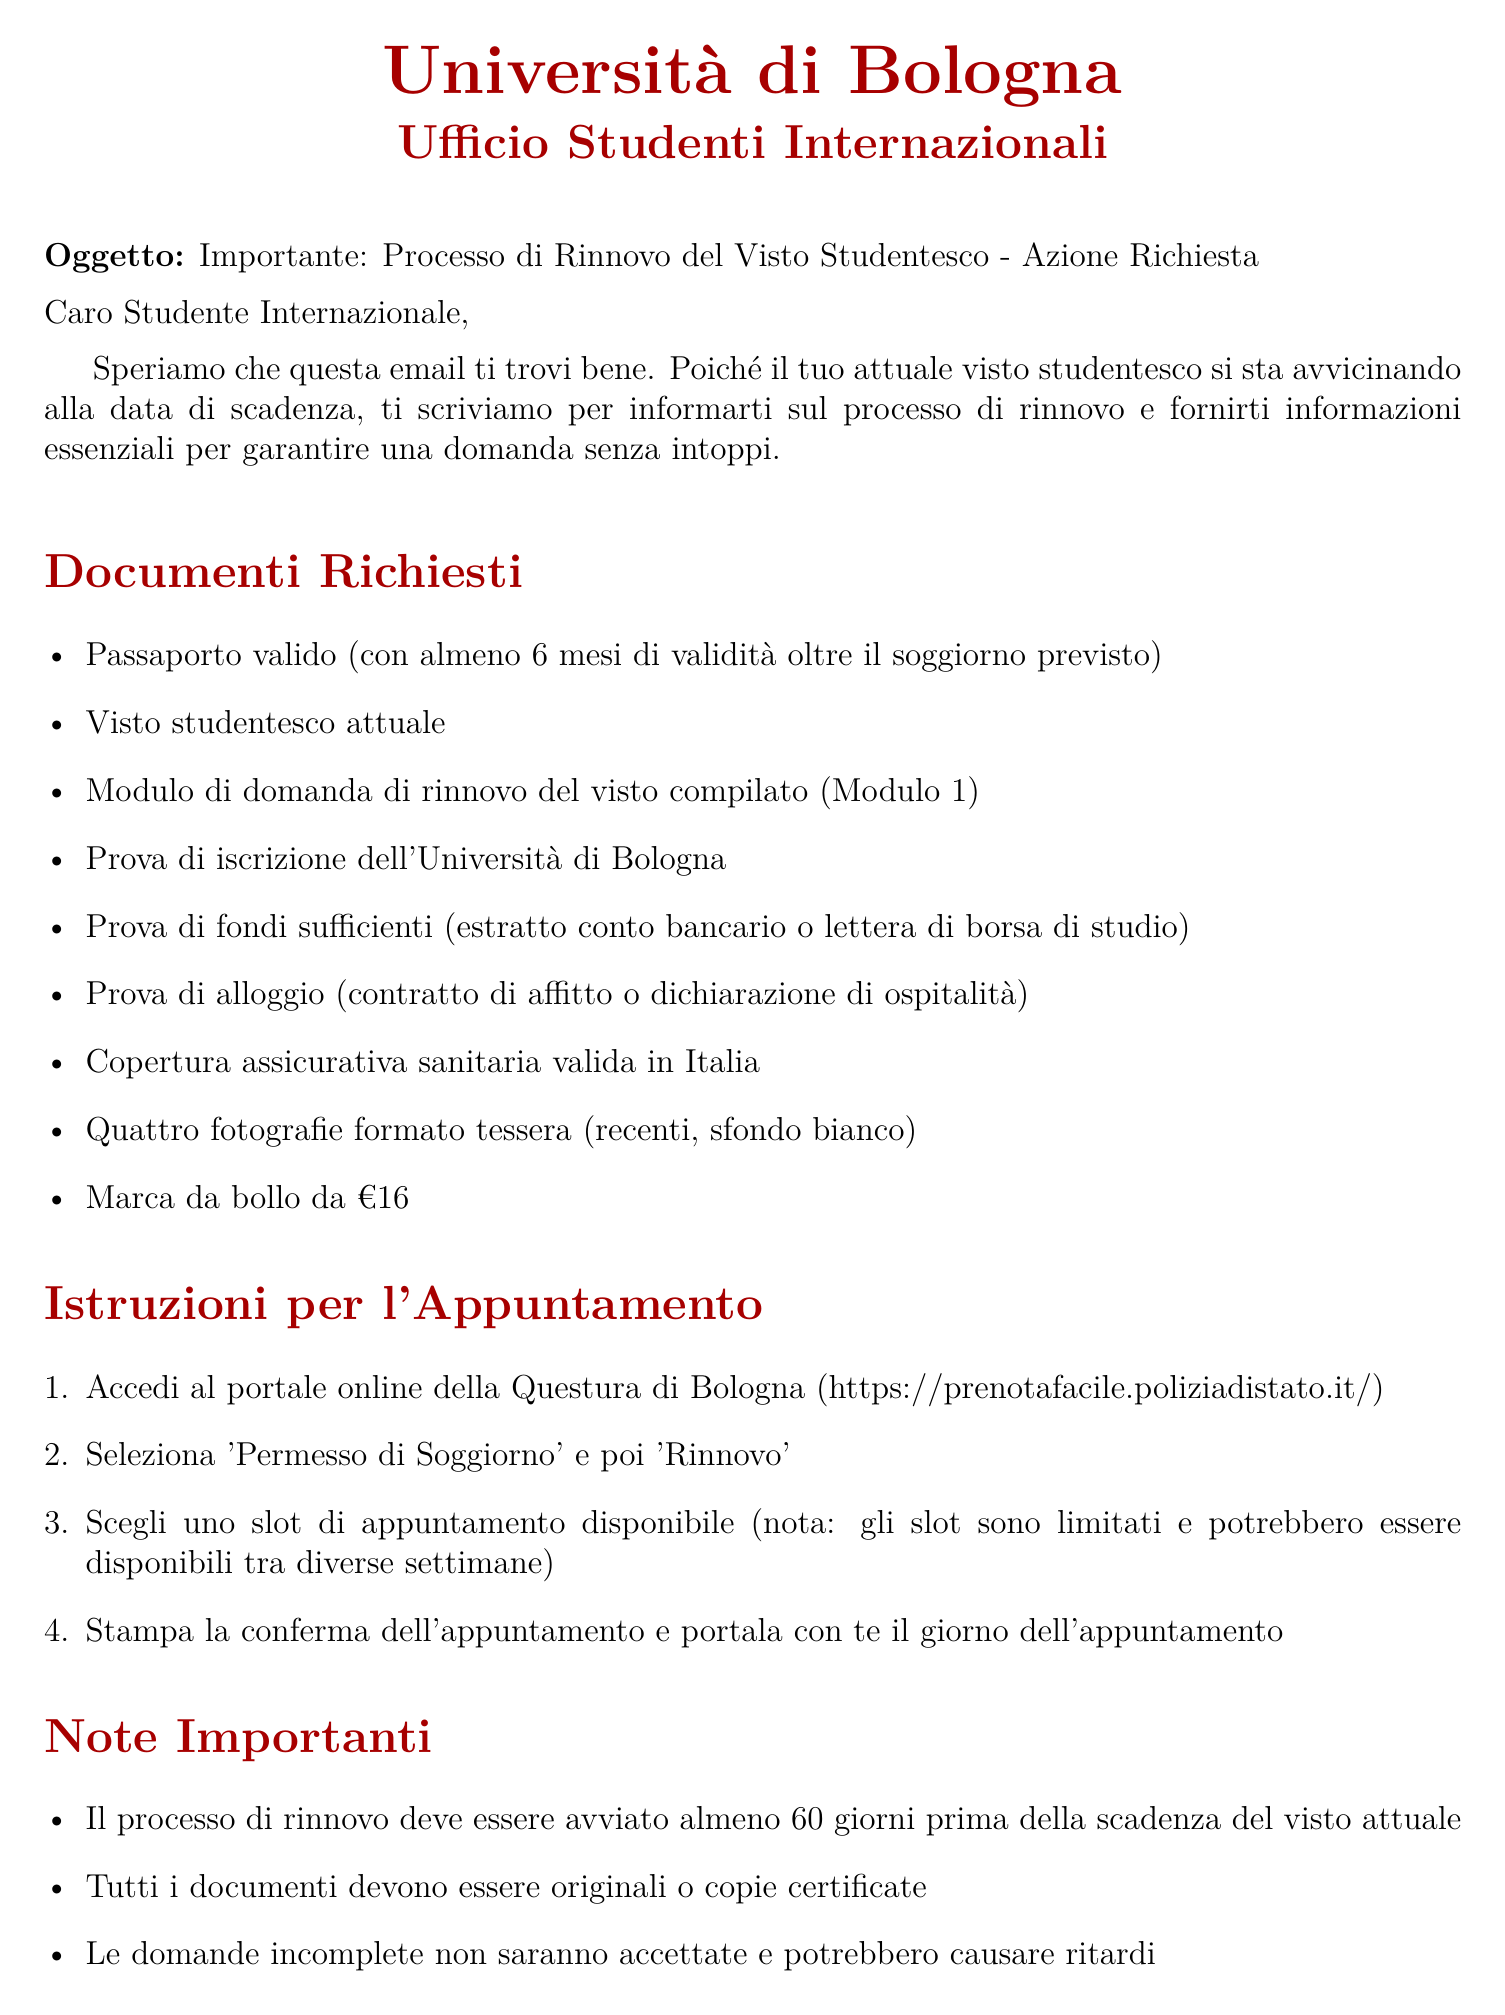What is the subject of the email? The subject of the email is explicitly mentioned at the beginning of the document.
Answer: Important: Student Visa Renewal Process - Action Required Who is the sender of the email? The sender is identified at the end of the document, which includes the sender's name and office.
Answer: Marco Rossi How many passport-sized photographs are required? The requirement for photographs is specified in the list of documents.
Answer: Four When should the renewal process be initiated at the latest? The document states the time frame within which to initiate the renewal process.
Answer: 60 days What document proves enrollment at the University of Bologna? The list of required documents includes a specific proof for enrollment.
Answer: Proof of enrollment from the University of Bologna What is the cost of the revenue stamp? The amount for the revenue stamp is clearly stated in the required documents section.
Answer: €16 What must be done before selecting an appointment slot? This refers to a process outlined in the appointment instructions, highlighting steps to take.
Answer: Log in to the Questura di Bologna online portal What is one consequence of submitting an incomplete application? The document notes potential outcomes of submitting incomplete paperwork.
Answer: Delays What should you bring on the day of the appointment? This is mentioned in the appointment instructions section.
Answer: Appointment confirmation 